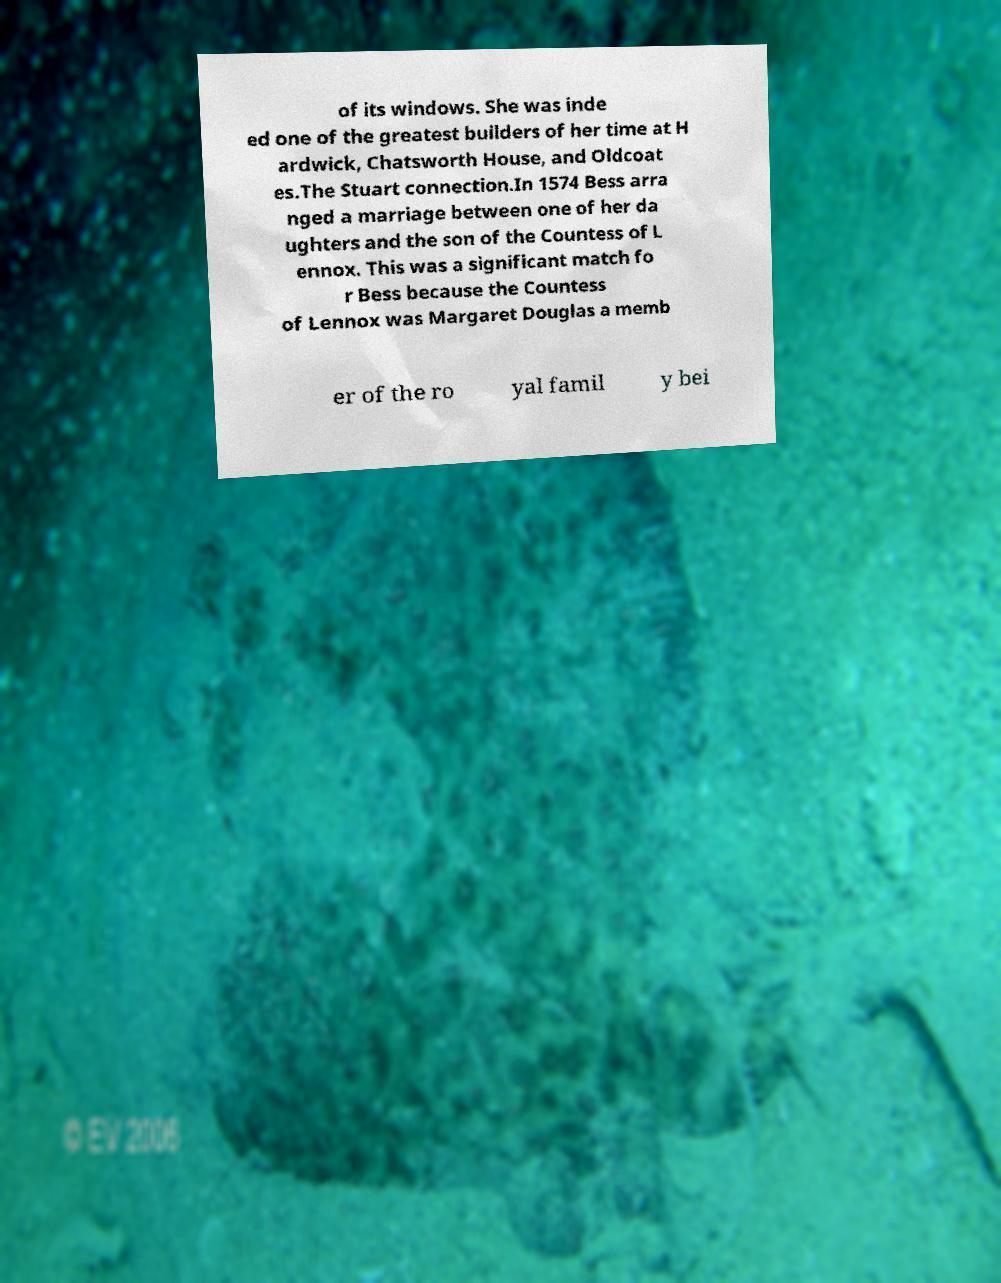There's text embedded in this image that I need extracted. Can you transcribe it verbatim? of its windows. She was inde ed one of the greatest builders of her time at H ardwick, Chatsworth House, and Oldcoat es.The Stuart connection.In 1574 Bess arra nged a marriage between one of her da ughters and the son of the Countess of L ennox. This was a significant match fo r Bess because the Countess of Lennox was Margaret Douglas a memb er of the ro yal famil y bei 